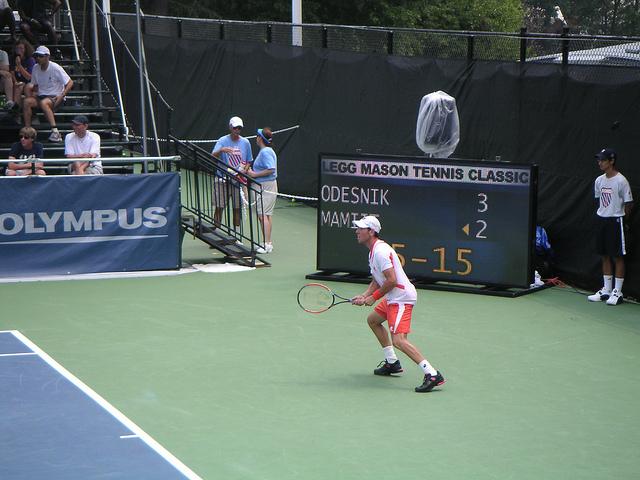What is the score?
Concise answer only. 3-2. Is the man in motion?
Be succinct. Yes. What is the player holding?
Keep it brief. Tennis racket. Are there white stripes on this man's shorts?
Give a very brief answer. Yes. 